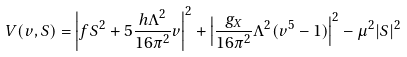Convert formula to latex. <formula><loc_0><loc_0><loc_500><loc_500>V ( v , S ) = \left | f S ^ { 2 } + 5 \frac { h \Lambda ^ { 2 } } { 1 6 \pi ^ { 2 } } v \right | ^ { 2 } + \left | \frac { g _ { X } } { 1 6 \pi ^ { 2 } } \Lambda ^ { 2 } ( v ^ { 5 } - 1 ) \right | ^ { 2 } - \mu ^ { 2 } | S | ^ { 2 }</formula> 